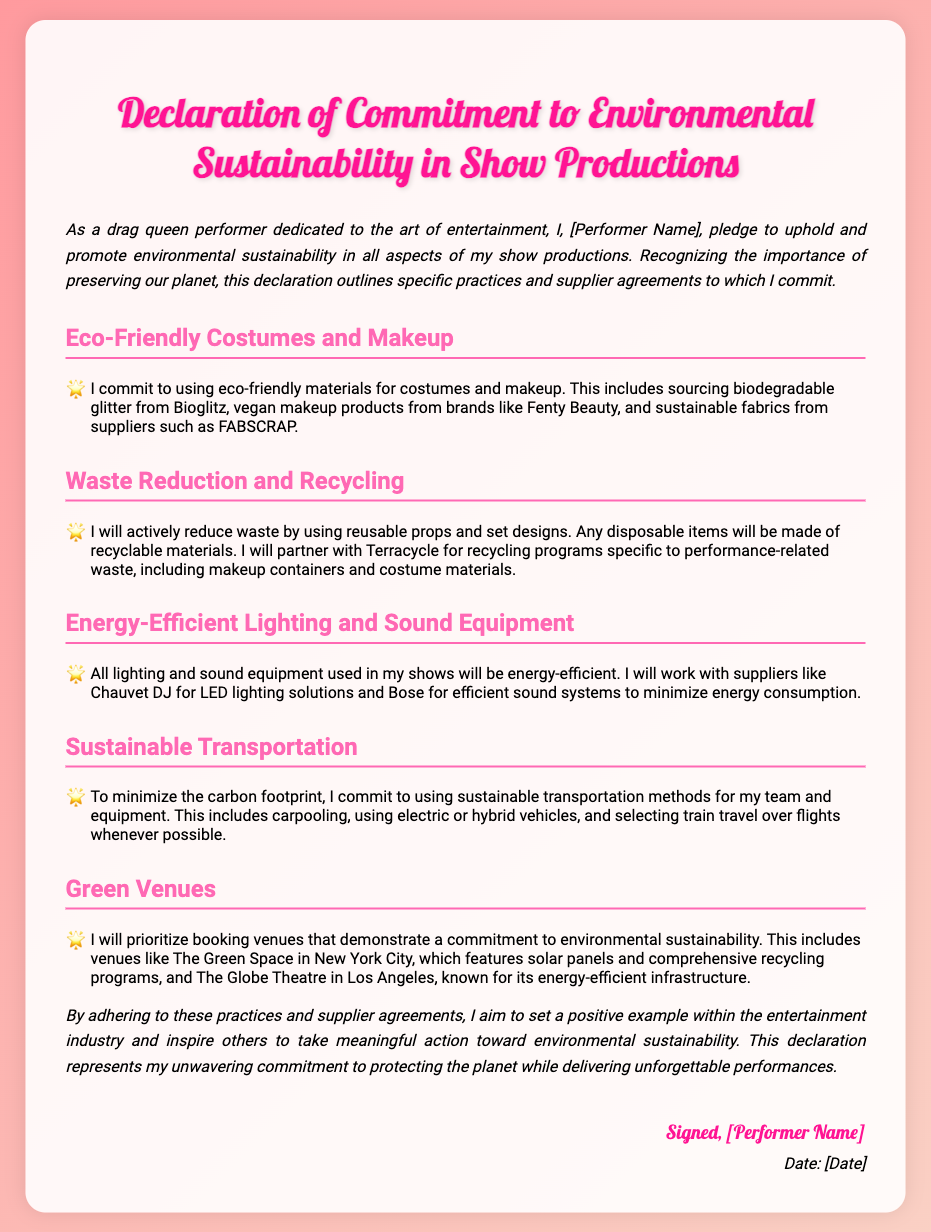What is the title of the document? The title of the document is stated at the top as "Declaration of Commitment to Environmental Sustainability in Show Productions."
Answer: Declaration of Commitment to Environmental Sustainability in Show Productions Who is making the commitment? The commitment is made by the performer, whose name will be written in the placeholder "[Performer Name]."
Answer: [Performer Name] What eco-friendly material is specified for costumes? The document mentions sourcing biodegradable glitter from Bioglitz as an eco-friendly material for costumes.
Answer: biodegradable glitter Which supplier is mentioned for energy-efficient lighting? The document specifies Chauvet DJ as the supplier for energy-efficient lighting solutions.
Answer: Chauvet DJ What sustainable transportation method is emphasized? The document emphasizes using carpooling as a method of sustainable transportation.
Answer: carpooling What venue is highlighted as an environmentally sustainable option? The document highlights The Green Space in New York City as an environmentally sustainable venue.
Answer: The Green Space How does the performer plan to handle performance-related waste? The performer plans to partner with Terracycle for recycling programs specific to performance-related waste.
Answer: Terracycle What is the date placeholder in the document for? The date placeholder is intended for inserting the date when the declaration is signed.
Answer: [Date] 